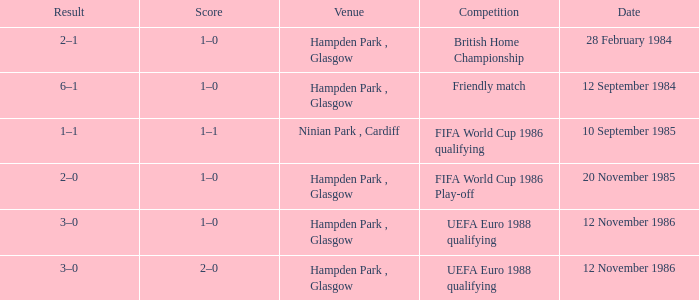What is the Score of the Fifa World Cup 1986 Play-off Competition? 1–0. 